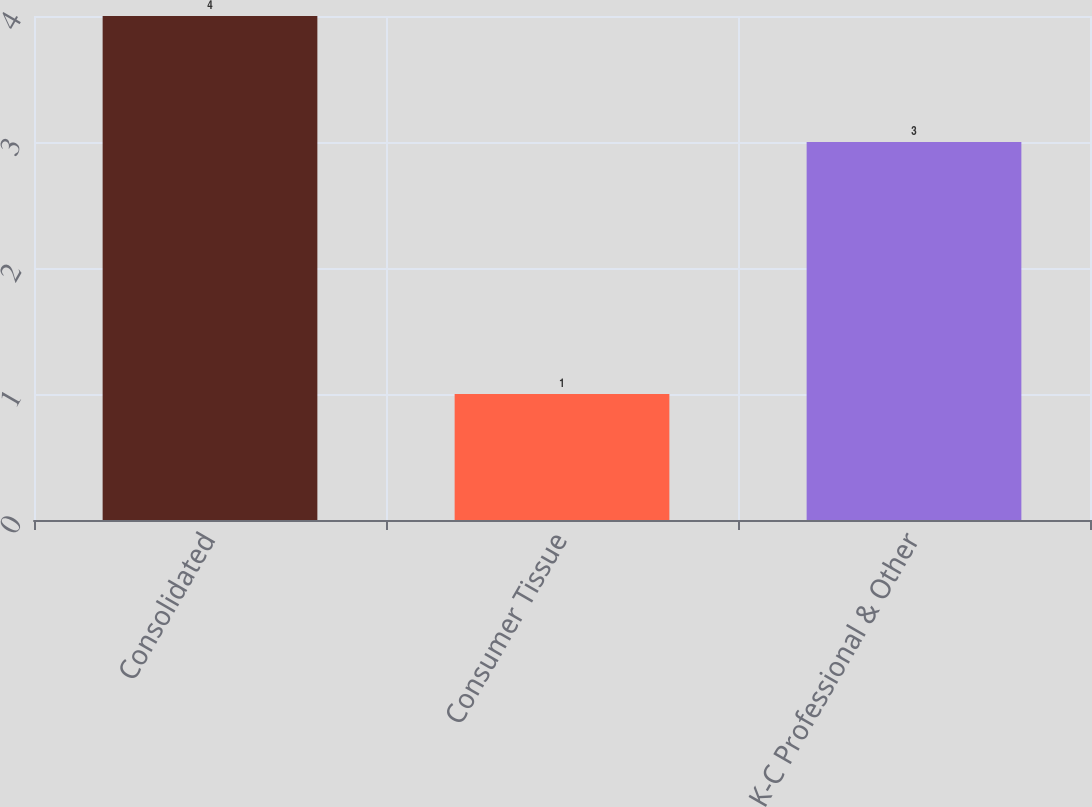Convert chart to OTSL. <chart><loc_0><loc_0><loc_500><loc_500><bar_chart><fcel>Consolidated<fcel>Consumer Tissue<fcel>K-C Professional & Other<nl><fcel>4<fcel>1<fcel>3<nl></chart> 